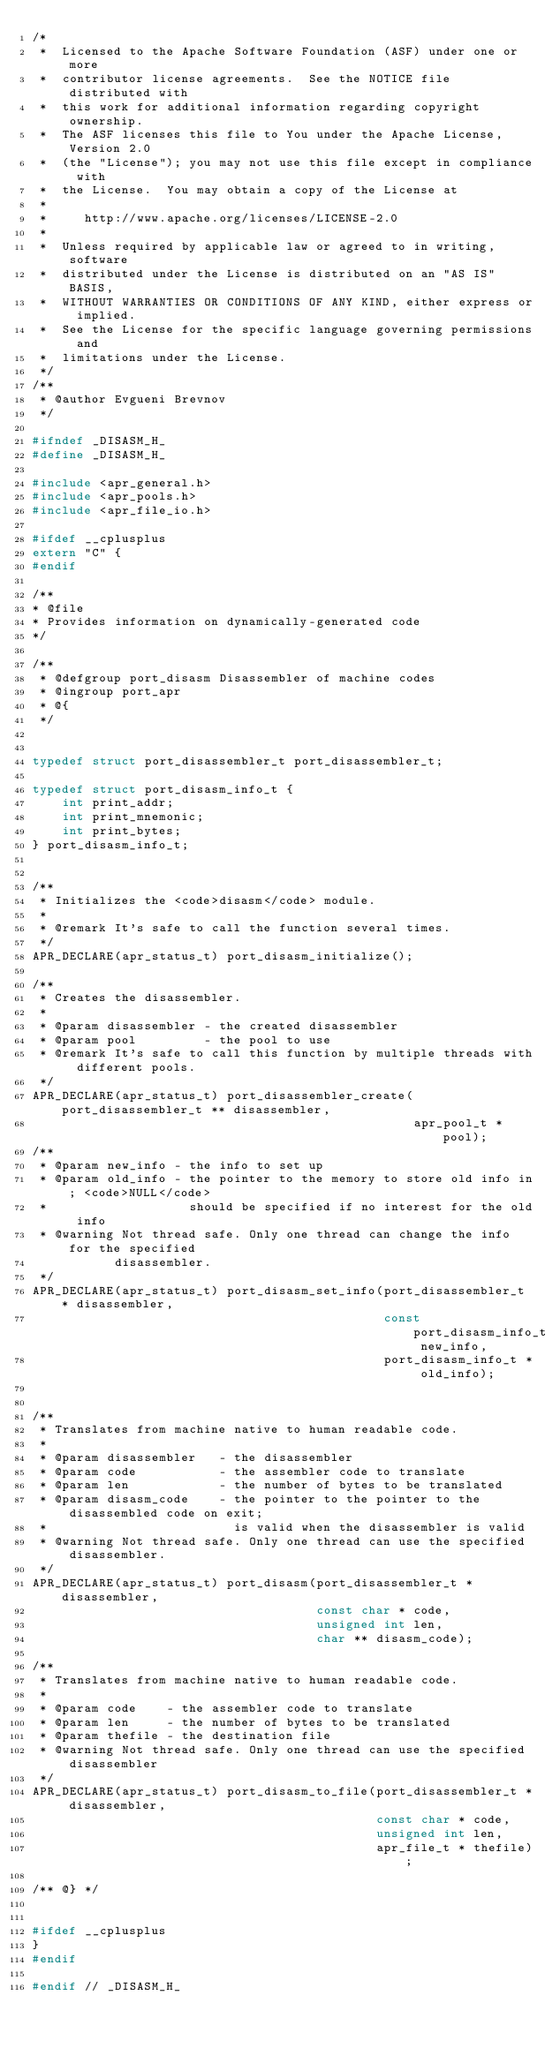Convert code to text. <code><loc_0><loc_0><loc_500><loc_500><_C_>/*
 *  Licensed to the Apache Software Foundation (ASF) under one or more
 *  contributor license agreements.  See the NOTICE file distributed with
 *  this work for additional information regarding copyright ownership.
 *  The ASF licenses this file to You under the Apache License, Version 2.0
 *  (the "License"); you may not use this file except in compliance with
 *  the License.  You may obtain a copy of the License at
 *
 *     http://www.apache.org/licenses/LICENSE-2.0
 *
 *  Unless required by applicable law or agreed to in writing, software
 *  distributed under the License is distributed on an "AS IS" BASIS,
 *  WITHOUT WARRANTIES OR CONDITIONS OF ANY KIND, either express or implied.
 *  See the License for the specific language governing permissions and
 *  limitations under the License.
 */
/**
 * @author Evgueni Brevnov
 */

#ifndef _DISASM_H_
#define _DISASM_H_

#include <apr_general.h>
#include <apr_pools.h>
#include <apr_file_io.h>

#ifdef __cplusplus
extern "C" {
#endif

/**
* @file
* Provides information on dynamically-generated code
*/

/**
 * @defgroup port_disasm Disassembler of machine codes
 * @ingroup port_apr
 * @{
 */


typedef struct port_disassembler_t port_disassembler_t;

typedef struct port_disasm_info_t {
    int print_addr;
    int print_mnemonic;
    int print_bytes;
} port_disasm_info_t;


/**
 * Initializes the <code>disasm</code> module.
 *
 * @remark It's safe to call the function several times.
 */
APR_DECLARE(apr_status_t) port_disasm_initialize();

/**
 * Creates the disassembler.
 *
 * @param disassembler - the created disassembler
 * @param pool         - the pool to use
 * @remark It's safe to call this function by multiple threads with different pools.
 */
APR_DECLARE(apr_status_t) port_disassembler_create(port_disassembler_t ** disassembler,
                                                   apr_pool_t * pool);
/**
 * @param new_info - the info to set up
 * @param old_info - the pointer to the memory to store old info in; <code>NULL</code> 
 *                   should be specified if no interest for the old info
 * @warning Not thread safe. Only one thread can change the info for the specified
           disassembler.
 */
APR_DECLARE(apr_status_t) port_disasm_set_info(port_disassembler_t * disassembler,
                                               const port_disasm_info_t new_info,
                                               port_disasm_info_t * old_info);


/**
 * Translates from machine native to human readable code.
 *
 * @param disassembler   - the disassembler
 * @param code           - the assembler code to translate
 * @param len            - the number of bytes to be translated
 * @param disasm_code    - the pointer to the pointer to the disassembled code on exit;
 *                         is valid when the disassembler is valid
 * @warning Not thread safe. Only one thread can use the specified disassembler.
 */
APR_DECLARE(apr_status_t) port_disasm(port_disassembler_t * disassembler,
                                      const char * code, 
                                      unsigned int len,
                                      char ** disasm_code);

/**
 * Translates from machine native to human readable code.
 *
 * @param code    - the assembler code to translate
 * @param len     - the number of bytes to be translated
 * @param thefile - the destination file
 * @warning Not thread safe. Only one thread can use the specified disassembler
 */
APR_DECLARE(apr_status_t) port_disasm_to_file(port_disassembler_t * disassembler,
                                              const char * code,
                                              unsigned int len,
                                              apr_file_t * thefile);

/** @} */


#ifdef __cplusplus
}
#endif

#endif // _DISASM_H_




</code> 